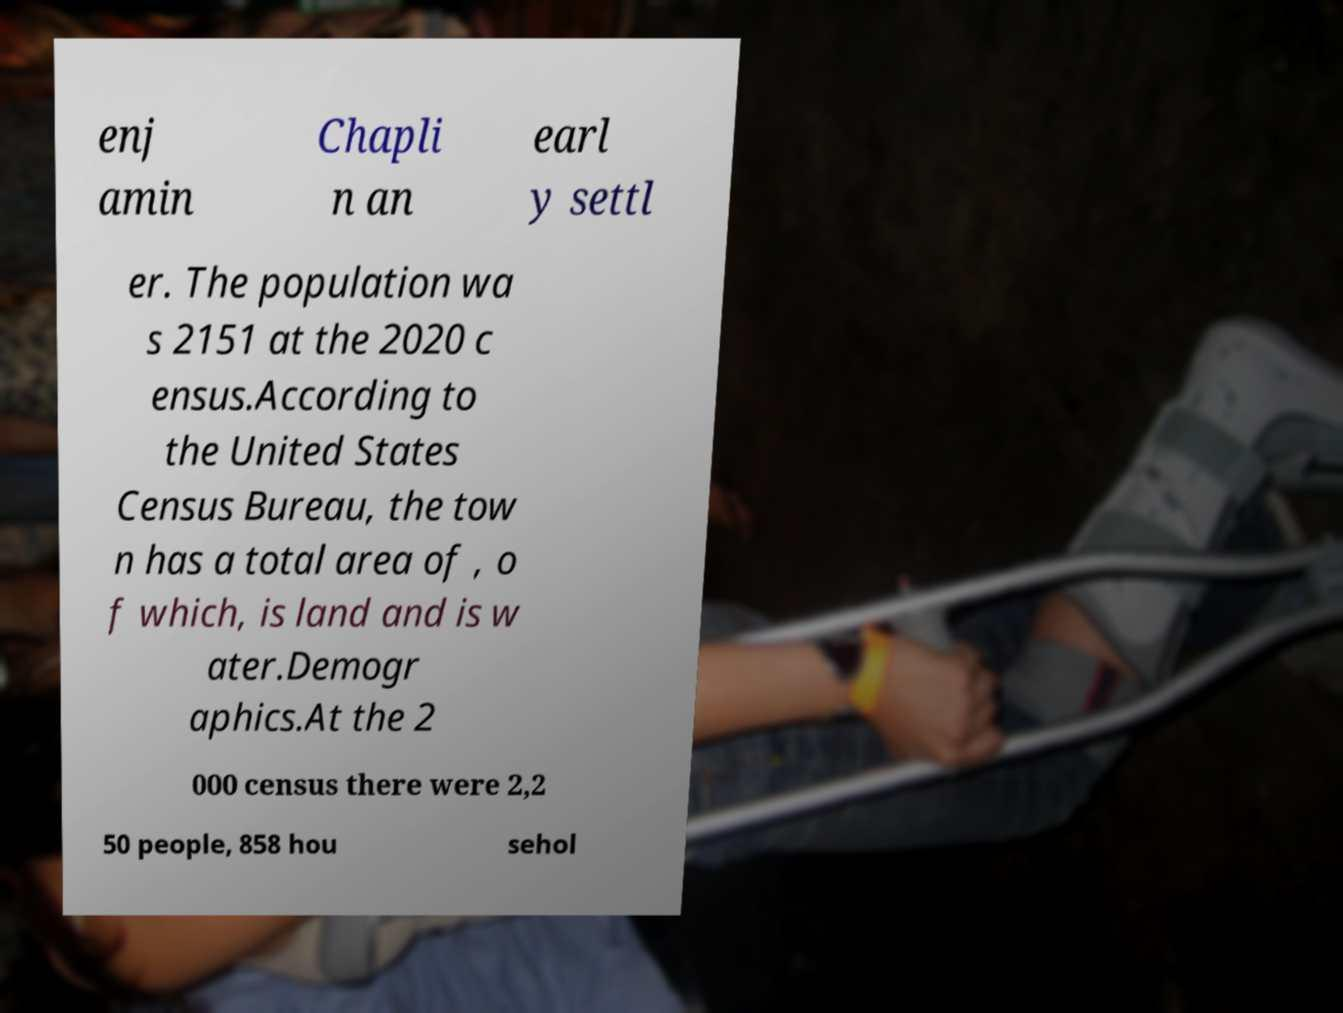Could you extract and type out the text from this image? enj amin Chapli n an earl y settl er. The population wa s 2151 at the 2020 c ensus.According to the United States Census Bureau, the tow n has a total area of , o f which, is land and is w ater.Demogr aphics.At the 2 000 census there were 2,2 50 people, 858 hou sehol 